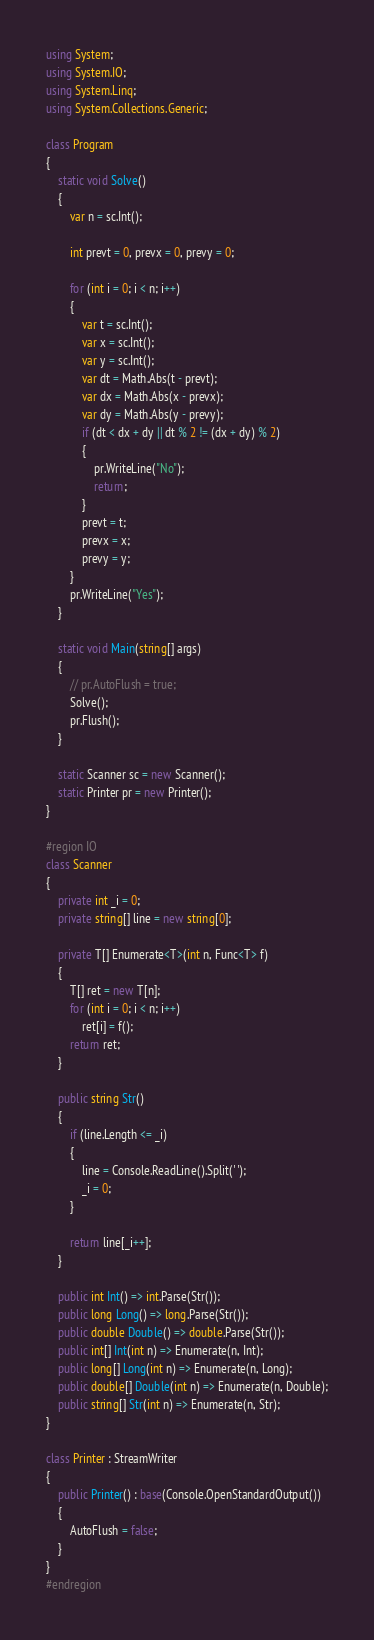<code> <loc_0><loc_0><loc_500><loc_500><_C#_>using System;
using System.IO;
using System.Linq;
using System.Collections.Generic;

class Program
{
    static void Solve()
    {
        var n = sc.Int();

        int prevt = 0, prevx = 0, prevy = 0;

        for (int i = 0; i < n; i++)
        {
            var t = sc.Int();
            var x = sc.Int();
            var y = sc.Int();
            var dt = Math.Abs(t - prevt);
            var dx = Math.Abs(x - prevx);
            var dy = Math.Abs(y - prevy);
            if (dt < dx + dy || dt % 2 != (dx + dy) % 2)
            {
                pr.WriteLine("No");
                return;
            }
            prevt = t;
            prevx = x;
            prevy = y;
        }
        pr.WriteLine("Yes");
    }

    static void Main(string[] args)
    {
        // pr.AutoFlush = true;
        Solve();
        pr.Flush();
    }

    static Scanner sc = new Scanner();
    static Printer pr = new Printer();
}

#region IO
class Scanner
{
    private int _i = 0;
    private string[] line = new string[0];

    private T[] Enumerate<T>(int n, Func<T> f)
    {
        T[] ret = new T[n];
        for (int i = 0; i < n; i++)
            ret[i] = f();
        return ret;
    }

    public string Str()
    {
        if (line.Length <= _i)
        {
            line = Console.ReadLine().Split(' ');
            _i = 0;
        }

        return line[_i++];
    }

    public int Int() => int.Parse(Str());
    public long Long() => long.Parse(Str());
    public double Double() => double.Parse(Str());
    public int[] Int(int n) => Enumerate(n, Int);
    public long[] Long(int n) => Enumerate(n, Long);
    public double[] Double(int n) => Enumerate(n, Double);
    public string[] Str(int n) => Enumerate(n, Str);
}

class Printer : StreamWriter
{
    public Printer() : base(Console.OpenStandardOutput())
    {
        AutoFlush = false;
    }
}
#endregion</code> 